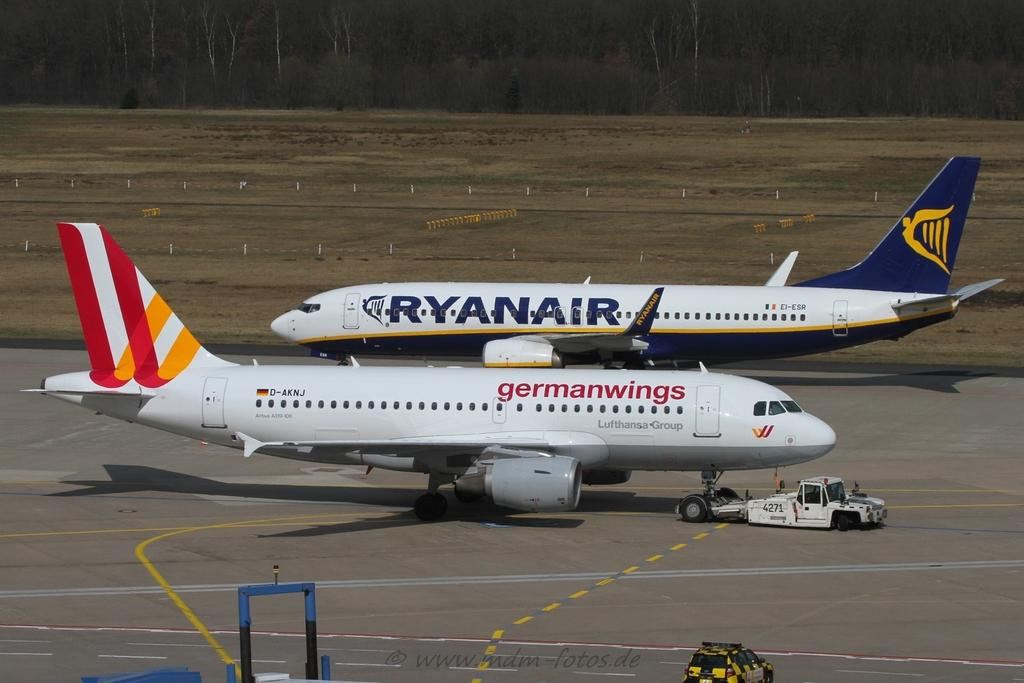<image>
Describe the image concisely. A Ryanair and a Germanwings aircraft both wait on the runway. 